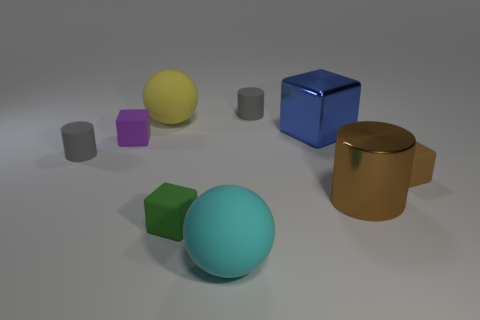Subtract 1 cubes. How many cubes are left? 3 Add 1 blocks. How many objects exist? 10 Subtract all cylinders. How many objects are left? 6 Subtract all cylinders. Subtract all rubber spheres. How many objects are left? 4 Add 2 big blocks. How many big blocks are left? 3 Add 4 tiny yellow metal cylinders. How many tiny yellow metal cylinders exist? 4 Subtract 0 yellow blocks. How many objects are left? 9 